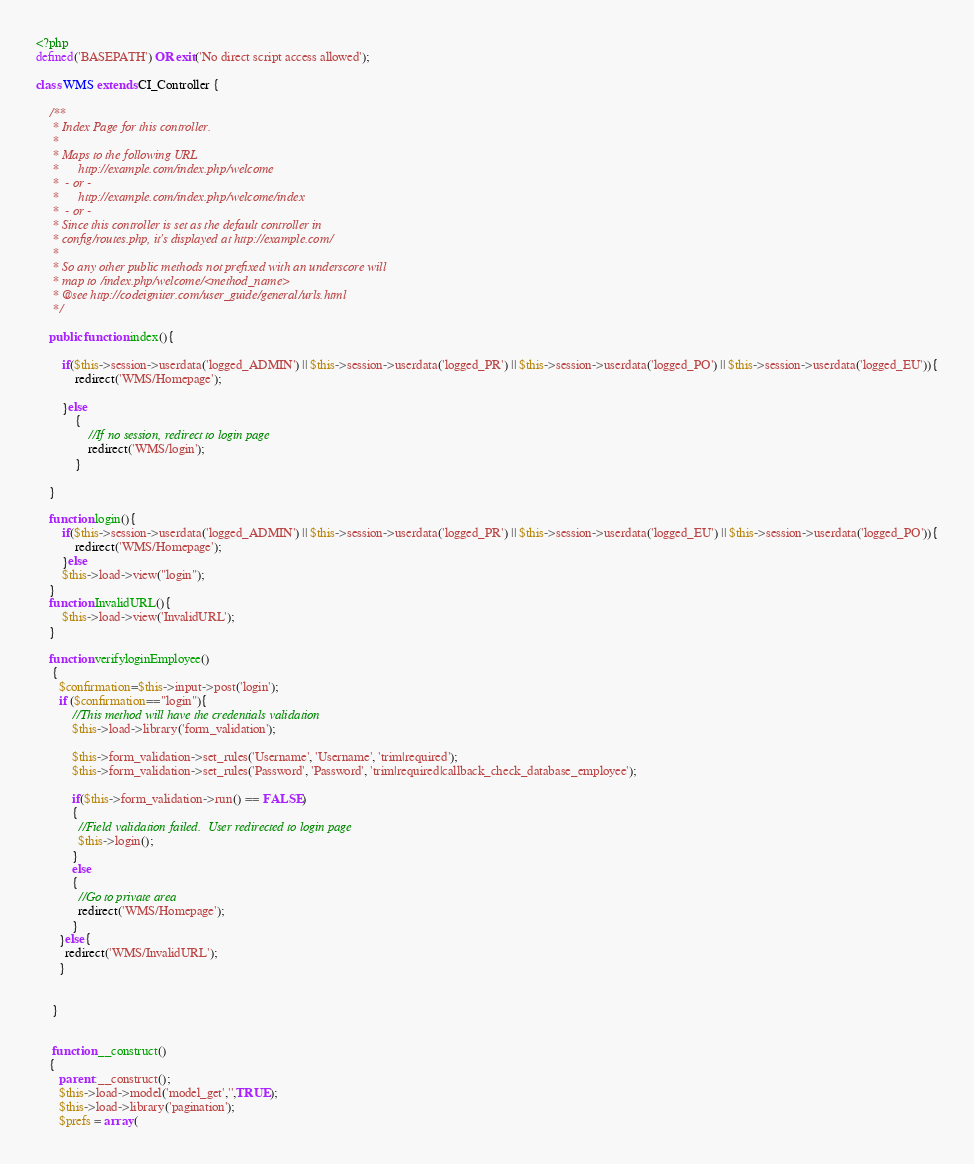Convert code to text. <code><loc_0><loc_0><loc_500><loc_500><_PHP_><?php
defined('BASEPATH') OR exit('No direct script access allowed');

class WMS extends CI_Controller {

	/**
	 * Index Page for this controller.
	 *
	 * Maps to the following URL
	 * 		http://example.com/index.php/welcome
	 *	- or -
	 * 		http://example.com/index.php/welcome/index
	 *	- or -
	 * Since this controller is set as the default controller in
	 * config/routes.php, it's displayed at http://example.com/
	 *
	 * So any other public methods not prefixed with an underscore will
	 * map to /index.php/welcome/<method_name>
	 * @see http://codeigniter.com/user_guide/general/urls.html
	 */

	public function index(){
	
		if($this->session->userdata('logged_ADMIN') || $this->session->userdata('logged_PR') || $this->session->userdata('logged_PO') || $this->session->userdata('logged_EU')){
			redirect('WMS/Homepage');
			
		}else
			{
				//If no session, redirect to login page
				redirect('WMS/login');
			}
	
	}
	
	function login(){
		if($this->session->userdata('logged_ADMIN') || $this->session->userdata('logged_PR') || $this->session->userdata('logged_EU') || $this->session->userdata('logged_PO')){
			redirect('WMS/Homepage');
		}else
		$this->load->view("login");
	}
	function InvalidURL(){
		$this->load->view('InvalidURL');
	}
	
	function verifyloginEmployee()
	 {
	   $confirmation=$this->input->post('login');
	   if ($confirmation=="login"){
		   //This method will have the credentials validation
		   $this->load->library('form_validation');

		   $this->form_validation->set_rules('Username', 'Username', 'trim|required');
		   $this->form_validation->set_rules('Password', 'Password', 'trim|required|callback_check_database_employee');

		   if($this->form_validation->run() == FALSE)
		   {
			 //Field validation failed.  User redirected to login page
			 $this->login();
		   }
		   else
		   {
			 //Go to private area
			 redirect('WMS/Homepage');
		   }
	   }else{
		 redirect('WMS/InvalidURL');
	   }
	   
	   
	 }
	 
	 
	 function __construct()
	{
	   parent::__construct();
	   $this->load->model('model_get','',TRUE);
	   $this->load->library('pagination');
	   $prefs = array (</code> 